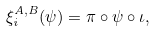Convert formula to latex. <formula><loc_0><loc_0><loc_500><loc_500>\xi _ { i } ^ { A , B } ( \psi ) = \pi \circ \psi \circ \iota ,</formula> 